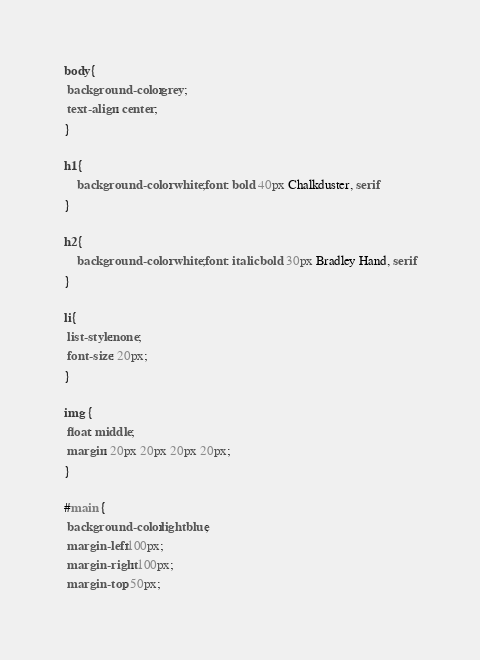Convert code to text. <code><loc_0><loc_0><loc_500><loc_500><_CSS_>body{
 background-color:grey;
 text-align: center;
}

h1{
	background-color: white;font: bold 40px Chalkduster, serif
}

h2{
	background-color: white;font: italic bold 30px Bradley Hand, serif
}

li{
 list-style:none;
 font-size: 20px;
}

img {
 float: middle;
 margin: 20px 20px 20px 20px;
}

#main {
 background-color:lightblue;
 margin-left:100px;
 margin-right: 100px;
 margin-top: 50px;</code> 